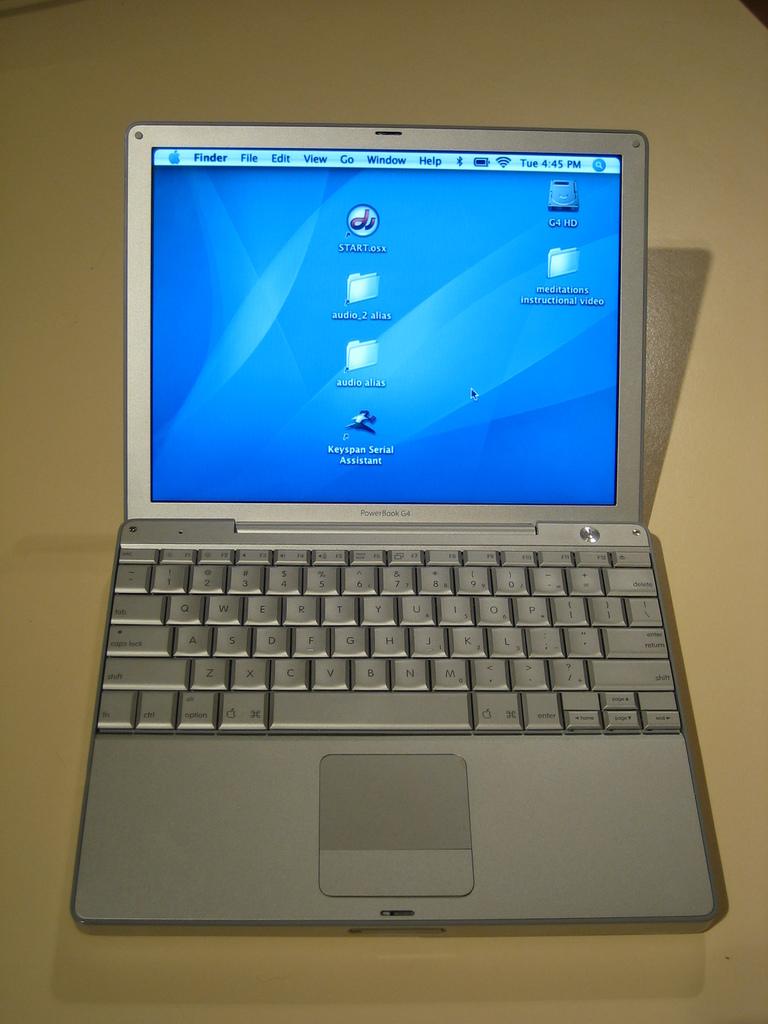What early apple device is this?
Ensure brevity in your answer.  Powerbook g4. What does the top right corner icon say on the screen?
Your answer should be very brief. G4 hd. 